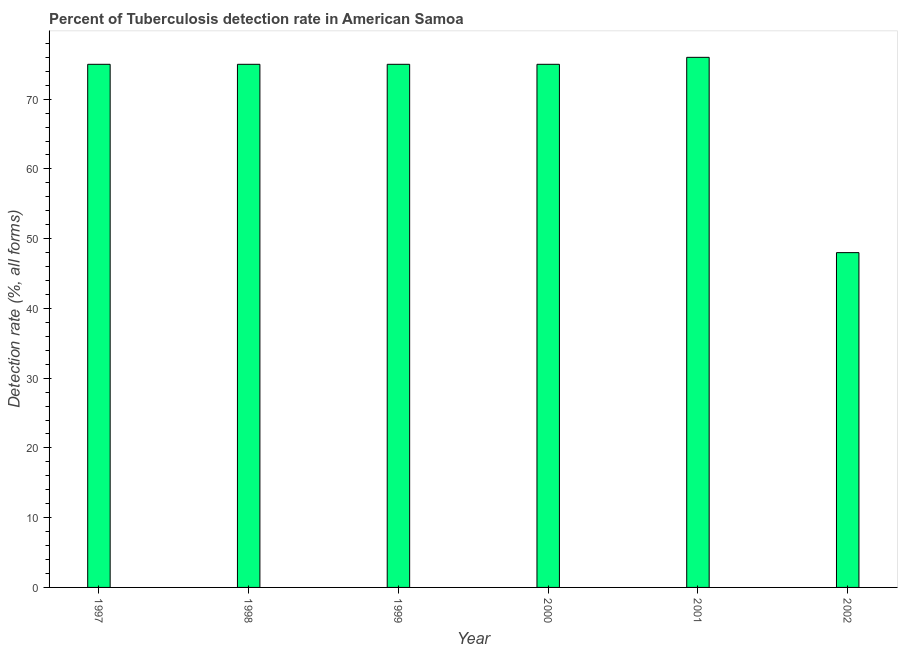Does the graph contain grids?
Provide a succinct answer. No. What is the title of the graph?
Your answer should be very brief. Percent of Tuberculosis detection rate in American Samoa. What is the label or title of the X-axis?
Make the answer very short. Year. What is the label or title of the Y-axis?
Make the answer very short. Detection rate (%, all forms). What is the detection rate of tuberculosis in 2001?
Give a very brief answer. 76. Across all years, what is the maximum detection rate of tuberculosis?
Keep it short and to the point. 76. In which year was the detection rate of tuberculosis maximum?
Offer a terse response. 2001. In which year was the detection rate of tuberculosis minimum?
Provide a succinct answer. 2002. What is the sum of the detection rate of tuberculosis?
Offer a very short reply. 424. What is the difference between the detection rate of tuberculosis in 2000 and 2002?
Your answer should be compact. 27. What is the average detection rate of tuberculosis per year?
Provide a succinct answer. 70. What is the ratio of the detection rate of tuberculosis in 2000 to that in 2001?
Provide a short and direct response. 0.99. Is the detection rate of tuberculosis in 1999 less than that in 2002?
Provide a succinct answer. No. What is the difference between the highest and the second highest detection rate of tuberculosis?
Provide a short and direct response. 1. Is the sum of the detection rate of tuberculosis in 1999 and 2000 greater than the maximum detection rate of tuberculosis across all years?
Give a very brief answer. Yes. In how many years, is the detection rate of tuberculosis greater than the average detection rate of tuberculosis taken over all years?
Provide a short and direct response. 5. How many bars are there?
Ensure brevity in your answer.  6. Are all the bars in the graph horizontal?
Make the answer very short. No. Are the values on the major ticks of Y-axis written in scientific E-notation?
Provide a succinct answer. No. What is the Detection rate (%, all forms) in 1997?
Keep it short and to the point. 75. What is the Detection rate (%, all forms) of 1999?
Ensure brevity in your answer.  75. What is the Detection rate (%, all forms) of 2000?
Provide a short and direct response. 75. What is the difference between the Detection rate (%, all forms) in 1997 and 1998?
Provide a succinct answer. 0. What is the difference between the Detection rate (%, all forms) in 1997 and 2002?
Provide a succinct answer. 27. What is the difference between the Detection rate (%, all forms) in 1998 and 1999?
Make the answer very short. 0. What is the difference between the Detection rate (%, all forms) in 1998 and 2000?
Offer a very short reply. 0. What is the difference between the Detection rate (%, all forms) in 1998 and 2002?
Give a very brief answer. 27. What is the difference between the Detection rate (%, all forms) in 1999 and 2001?
Your answer should be compact. -1. What is the difference between the Detection rate (%, all forms) in 1999 and 2002?
Your answer should be compact. 27. What is the difference between the Detection rate (%, all forms) in 2000 and 2002?
Make the answer very short. 27. What is the difference between the Detection rate (%, all forms) in 2001 and 2002?
Give a very brief answer. 28. What is the ratio of the Detection rate (%, all forms) in 1997 to that in 1999?
Give a very brief answer. 1. What is the ratio of the Detection rate (%, all forms) in 1997 to that in 2002?
Ensure brevity in your answer.  1.56. What is the ratio of the Detection rate (%, all forms) in 1998 to that in 1999?
Offer a terse response. 1. What is the ratio of the Detection rate (%, all forms) in 1998 to that in 2001?
Offer a very short reply. 0.99. What is the ratio of the Detection rate (%, all forms) in 1998 to that in 2002?
Provide a short and direct response. 1.56. What is the ratio of the Detection rate (%, all forms) in 1999 to that in 2002?
Your response must be concise. 1.56. What is the ratio of the Detection rate (%, all forms) in 2000 to that in 2002?
Keep it short and to the point. 1.56. What is the ratio of the Detection rate (%, all forms) in 2001 to that in 2002?
Your response must be concise. 1.58. 